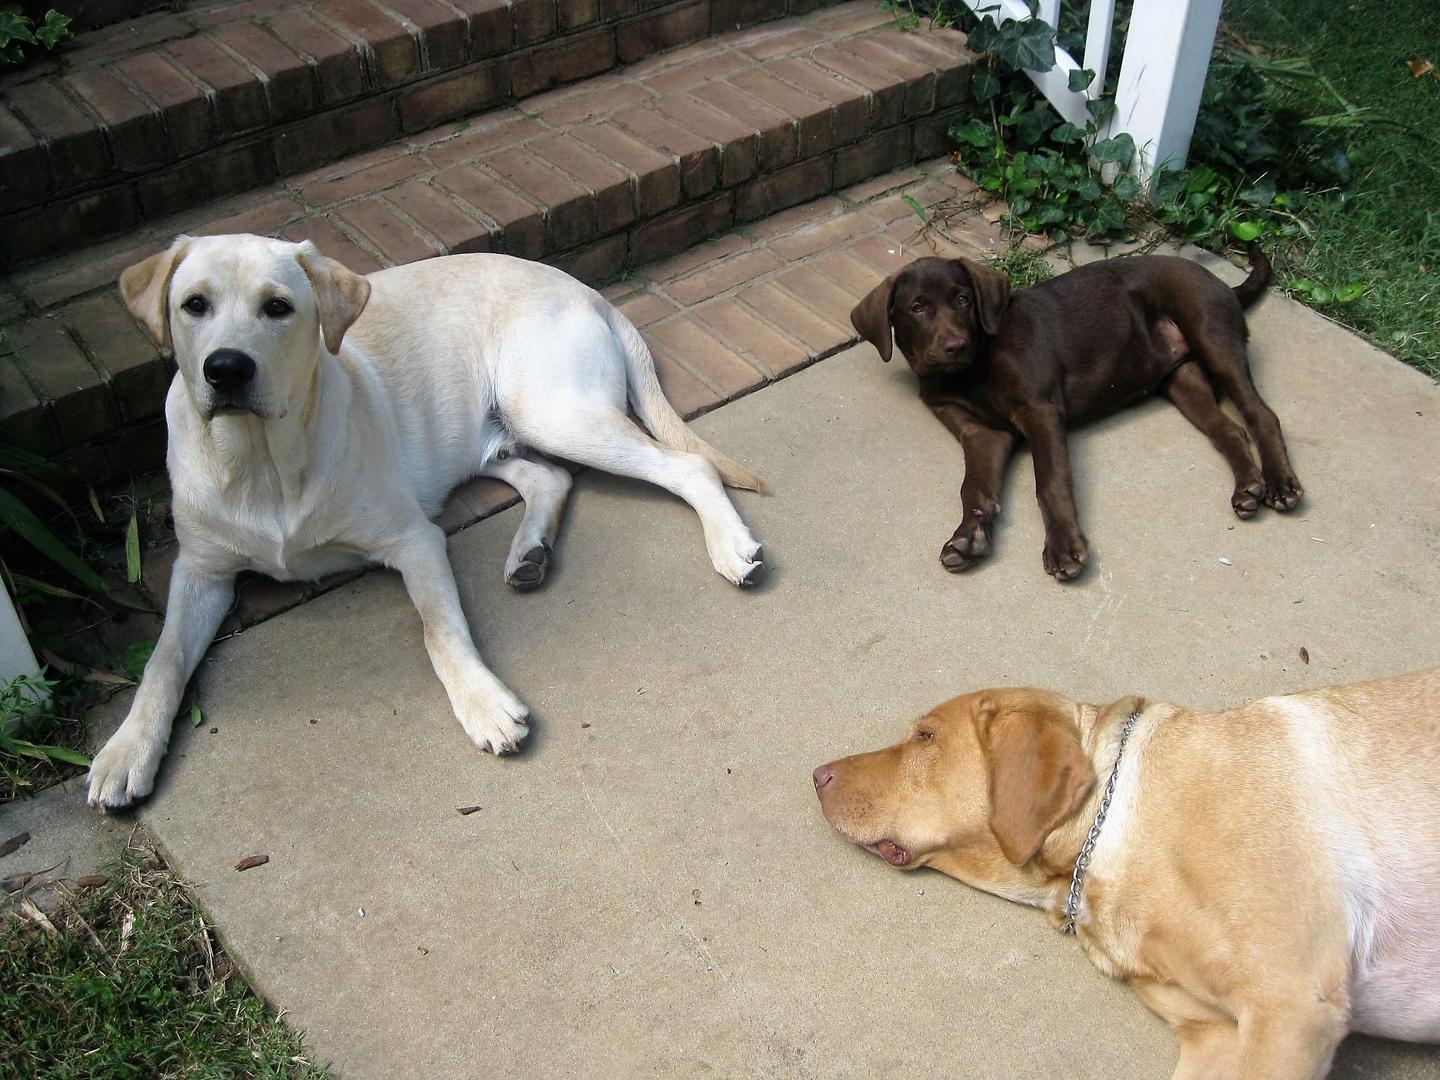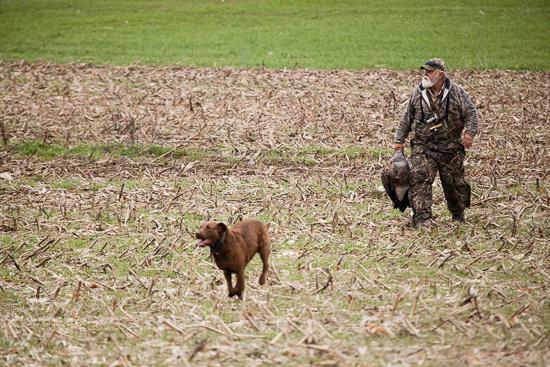The first image is the image on the left, the second image is the image on the right. Evaluate the accuracy of this statement regarding the images: "More than half a dozen dogs are lined up in each image.". Is it true? Answer yes or no. No. The first image is the image on the left, the second image is the image on the right. Analyze the images presented: Is the assertion "An image includes a hunting dog and a captured prey bird." valid? Answer yes or no. Yes. 